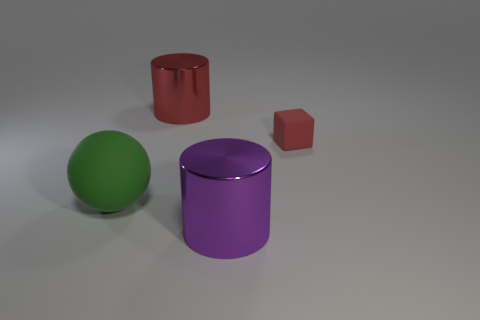Is there anything else that has the same size as the red block?
Keep it short and to the point. No. What number of other objects are there of the same material as the green ball?
Your response must be concise. 1. What is the tiny red block made of?
Your answer should be very brief. Rubber. What size is the rubber thing behind the matte sphere?
Provide a short and direct response. Small. How many large red things are to the right of the cylinder that is in front of the large red thing?
Offer a very short reply. 0. Do the metal thing behind the small red cube and the large rubber object to the left of the small red matte cube have the same shape?
Your answer should be very brief. No. What number of objects are on the right side of the matte ball and to the left of the matte cube?
Ensure brevity in your answer.  2. Are there any large metallic blocks of the same color as the big matte thing?
Offer a very short reply. No. What is the shape of the red metallic object that is the same size as the purple metallic cylinder?
Provide a succinct answer. Cylinder. There is a small red matte block; are there any red matte objects in front of it?
Give a very brief answer. No. 